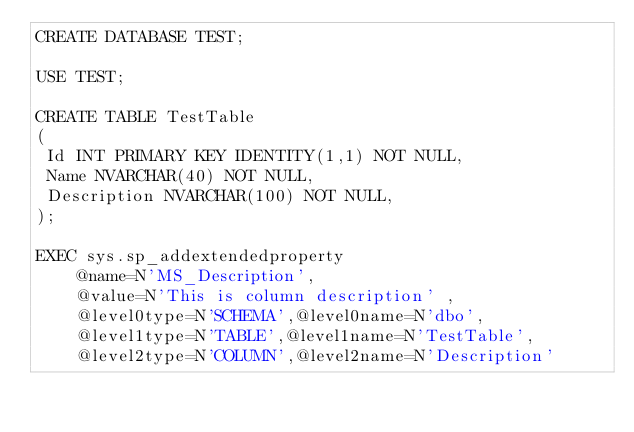Convert code to text. <code><loc_0><loc_0><loc_500><loc_500><_SQL_>CREATE DATABASE TEST;

USE TEST;

CREATE TABLE TestTable
(
 Id INT PRIMARY KEY IDENTITY(1,1) NOT NULL,
 Name NVARCHAR(40) NOT NULL,
 Description NVARCHAR(100) NOT NULL,
);

EXEC sys.sp_addextendedproperty
    @name=N'MS_Description',
    @value=N'This is column description' ,
    @level0type=N'SCHEMA',@level0name=N'dbo',
    @level1type=N'TABLE',@level1name=N'TestTable',
    @level2type=N'COLUMN',@level2name=N'Description'
</code> 